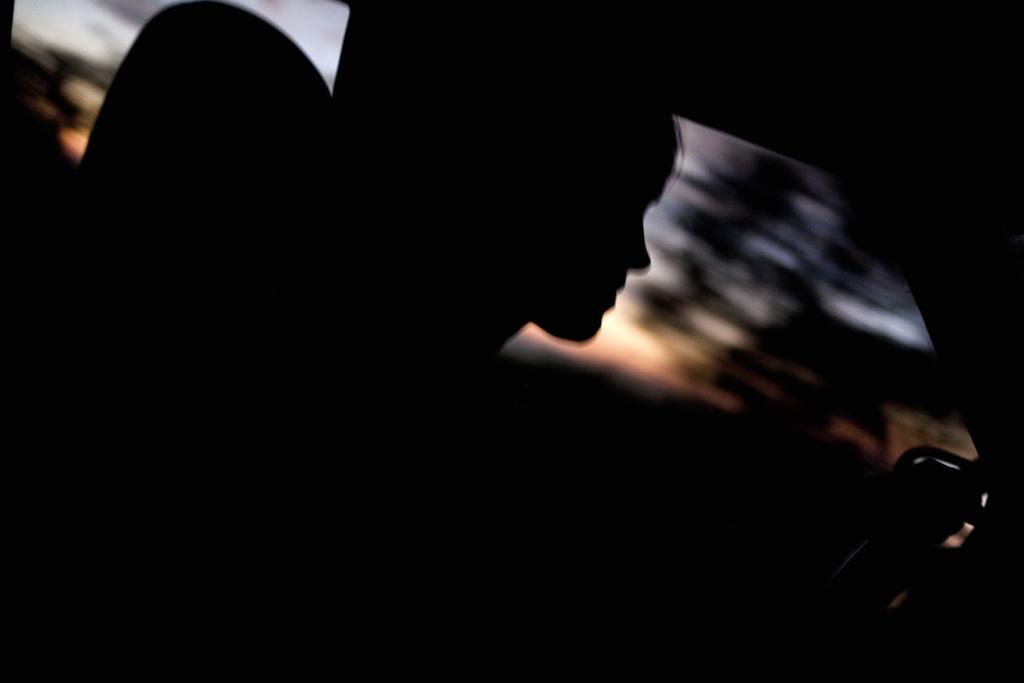What is the person in the image doing? There is a person sitting in a vehicle. What can be seen through the window glasses in the background? Trees and the sky are visible in the background through the window glasses. What type of calculator is the person using in the image? There is no calculator present in the image. What holiday is the person celebrating in the image? There is no indication of a holiday in the image. 